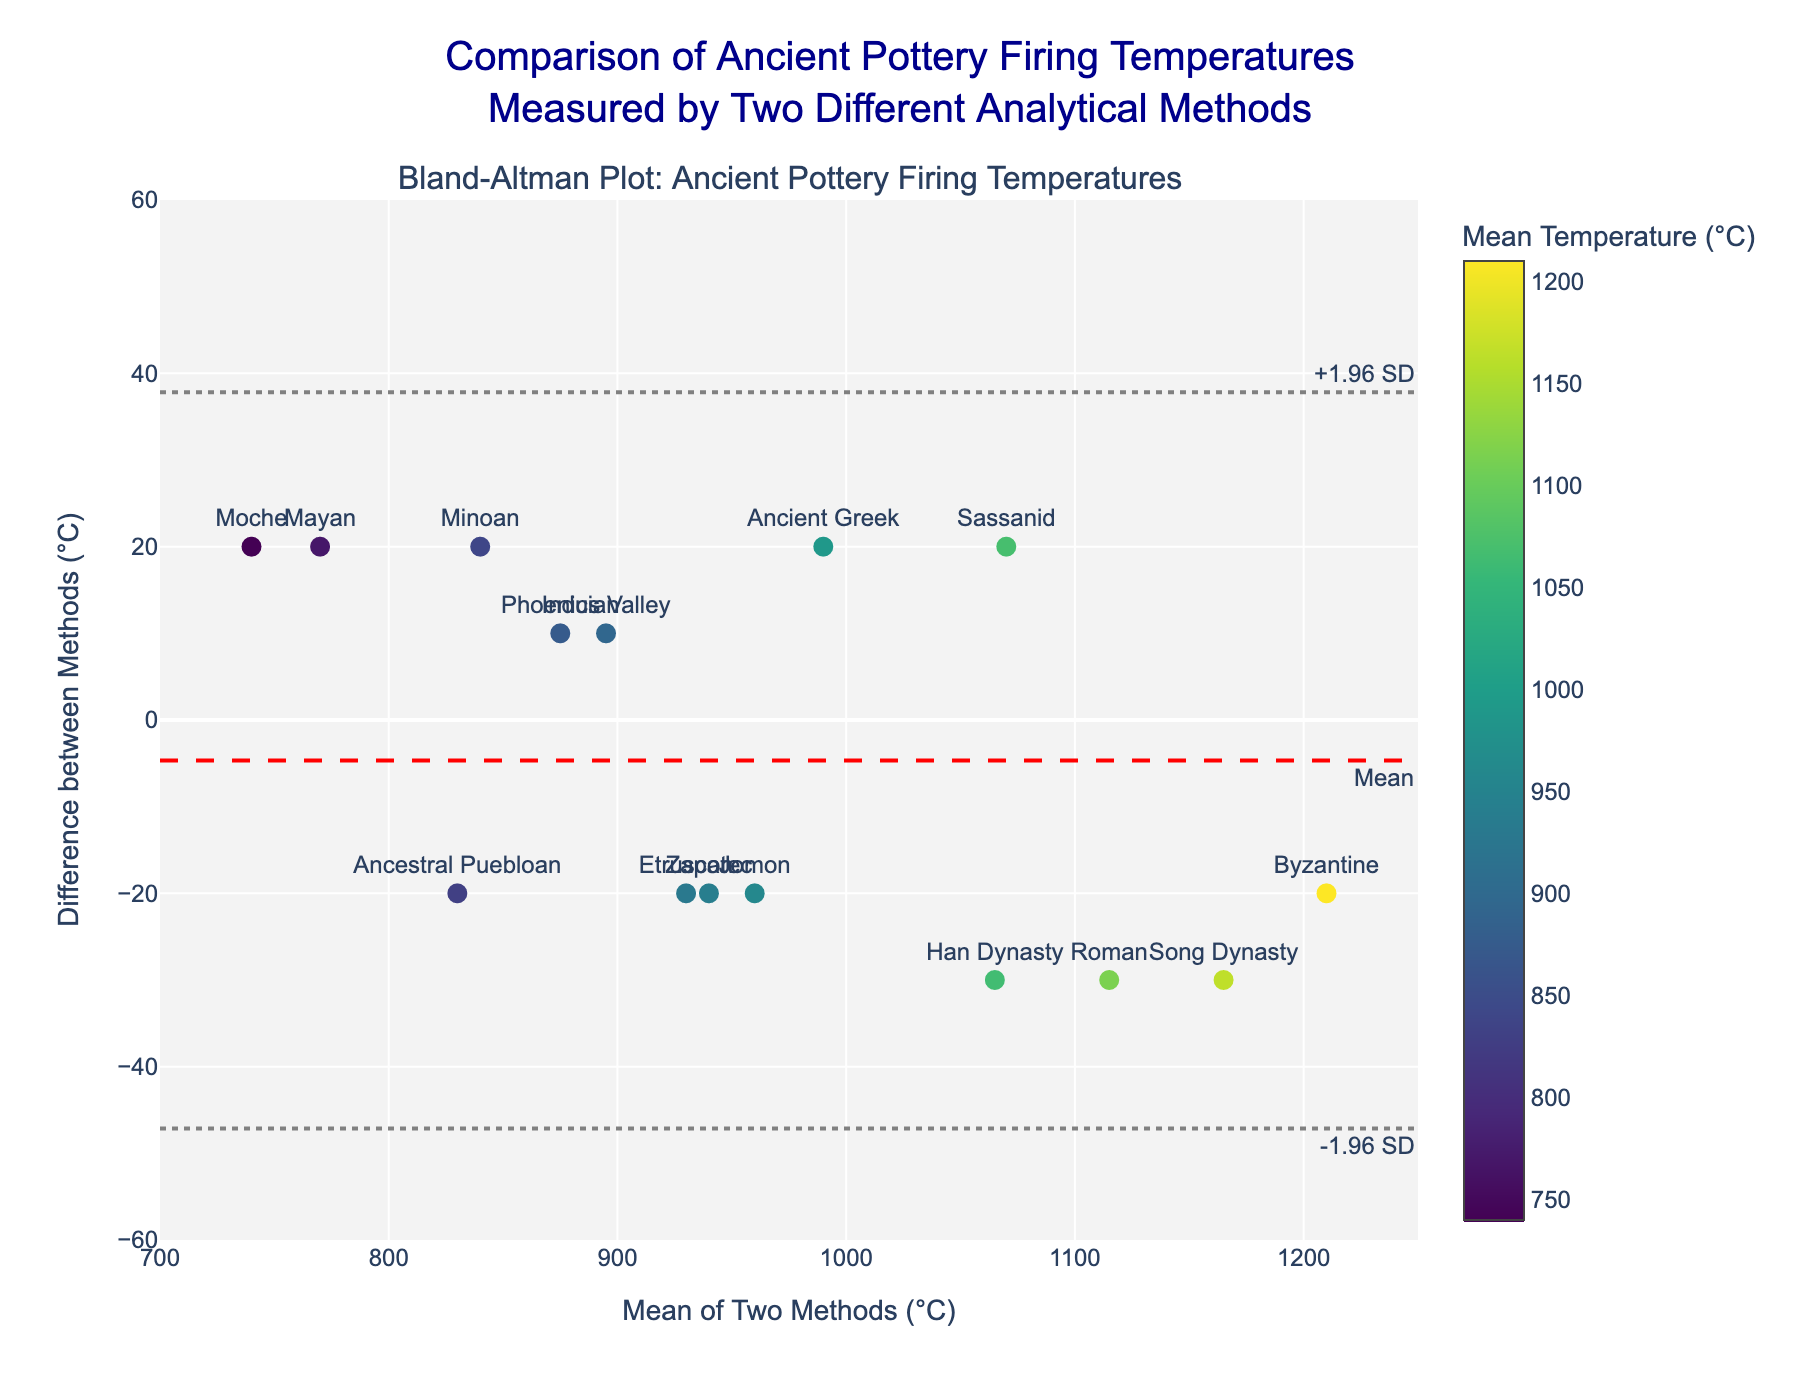How many cultures are represented in the plot? The plot uses markers with the names of different ancient cultures for each data point. We can count the number of unique culture names to find the number of represented cultures.
Answer: 15 What does the red dashed line in the plot represent? In a Bland-Altman plot, the red dashed line represents the mean difference between the two measurement methods. This line helps in identifying systematic bias between the methods.
Answer: Mean difference Which culture shows the smallest difference between the two methods? By looking at the y-values of the markers, the smallest difference (closest to zero) would correspond to the culture labeled with a marker located closest to the x-axis (zero line). The Ancestral Puebloan culture has a y-value of 20, which is the smallest in magnitude.
Answer: Ancestral Puebloan What range of mean temperatures is represented on the x-axis? The x-axis represents the mean temperature between the two methods. The x-axis range can be determined by looking at the axis ticks from the plot.
Answer: 700°C to 1250°C What is the difference in temperature for the Moche culture? The Moche culture's data point is identified on the plot with its label. The y-value of the Moche point represents the difference between the two methods.
Answer: 20°C What are the limits of agreement in the plot? The limits of agreement are shown as two gray dotted lines. They represent the mean difference plus or minus 1.96 times the standard deviation of the differences. These lines help identify outliers.
Answer: -36.6°C and 36.6°C Which culture has the largest positive difference between the two methods? To find the culture with the largest positive difference, locate the culture with the highest y-value above the zero line. The Song Dynasty has the largest positive difference.
Answer: Song Dynasty Are there any cultures with a negative difference between the two methods? On a Bland-Altman plot, a negative difference would be indicated by a point below the x-axis (zero line). By looking at the markers, cultures like the Han Dynasty and Indus Valley have negative differences.
Answer: Yes What color scale is used to indicate the mean temperature in the plot? The color of the markers corresponds to the mean temperature, with a color scale provided. The description mentions the Viridis color scale.
Answer: Viridis How many cultures have a difference that lies within the limits of agreement? To count the number of cultures within the limits of agreement, we need to observe which markers fall between the two gray dotted lines representing -1.96 SD and +1.96 SD. The plot shows 15 cultures, all of which lie within these limits.
Answer: 15 